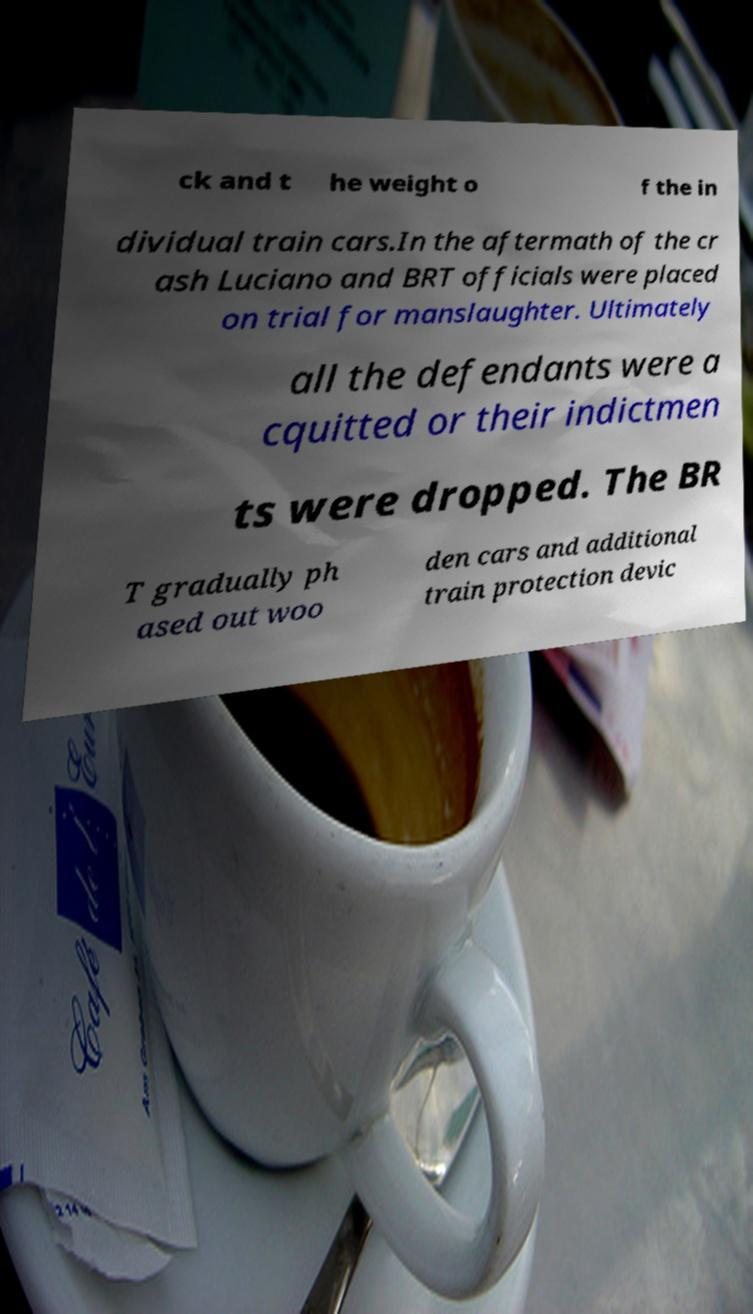Please read and relay the text visible in this image. What does it say? ck and t he weight o f the in dividual train cars.In the aftermath of the cr ash Luciano and BRT officials were placed on trial for manslaughter. Ultimately all the defendants were a cquitted or their indictmen ts were dropped. The BR T gradually ph ased out woo den cars and additional train protection devic 